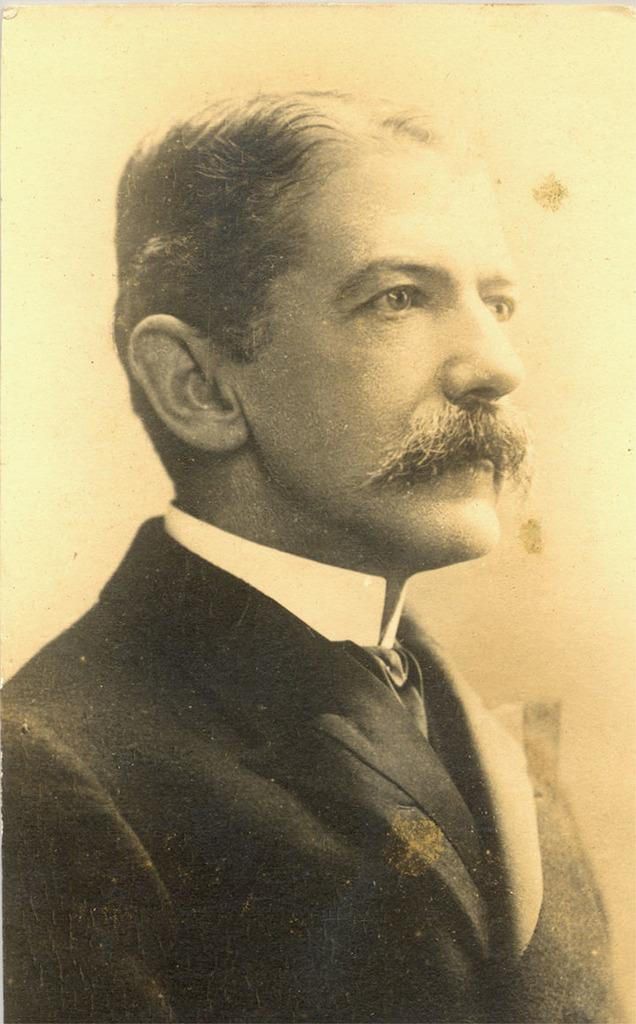Who is present in the image? There is a man in the image. What is the man wearing? The man is wearing a formal suit. What is the color scheme of the image? The image is in black and white color. Is there a baseball game happening in the image? There is no indication of a baseball game or any sports activity in the image. Does the existence of the man in the image prove the existence of extraterrestrial life? The presence of the man in the image does not provide any information about the existence of extraterrestrial life. 